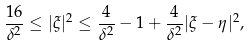<formula> <loc_0><loc_0><loc_500><loc_500>\frac { 1 6 } { \delta ^ { 2 } } \leq | \xi | ^ { 2 } \leq \frac { 4 } { \delta ^ { 2 } } - 1 + \frac { 4 } { \delta ^ { 2 } } | \xi - \eta | ^ { 2 } ,</formula> 